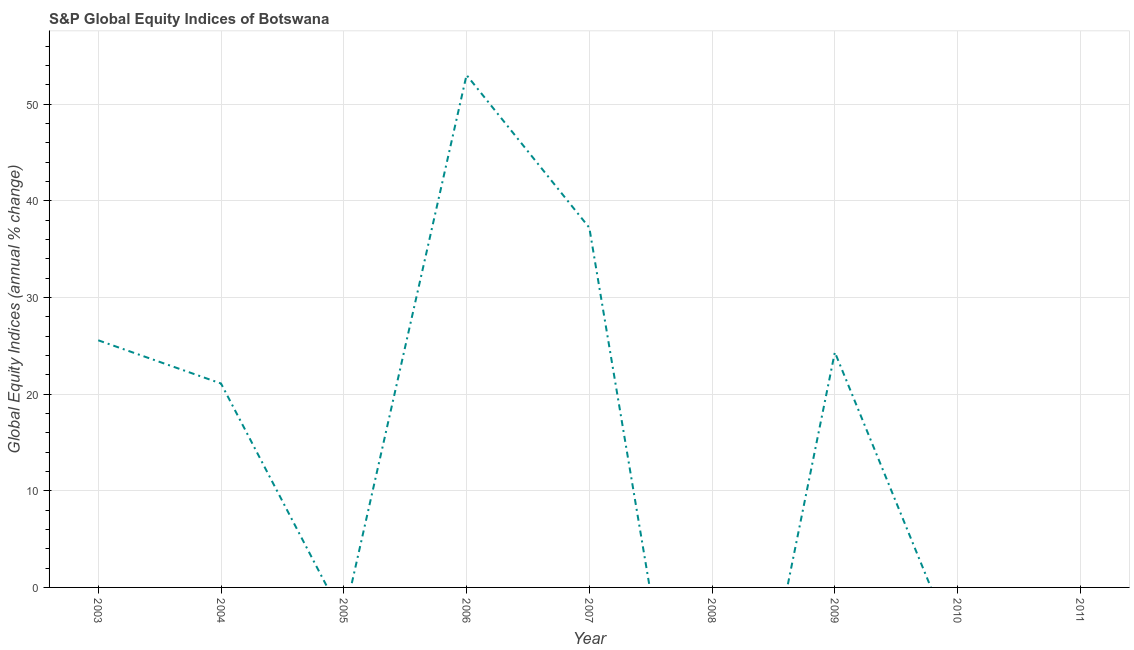What is the s&p global equity indices in 2007?
Keep it short and to the point. 37.21. Across all years, what is the maximum s&p global equity indices?
Offer a terse response. 53.02. In which year was the s&p global equity indices maximum?
Offer a very short reply. 2006. What is the sum of the s&p global equity indices?
Make the answer very short. 161.24. What is the difference between the s&p global equity indices in 2004 and 2006?
Keep it short and to the point. -31.92. What is the average s&p global equity indices per year?
Offer a terse response. 17.92. What is the median s&p global equity indices?
Provide a succinct answer. 21.1. In how many years, is the s&p global equity indices greater than 46 %?
Make the answer very short. 1. What is the ratio of the s&p global equity indices in 2004 to that in 2006?
Your response must be concise. 0.4. Is the difference between the s&p global equity indices in 2006 and 2007 greater than the difference between any two years?
Your response must be concise. No. What is the difference between the highest and the second highest s&p global equity indices?
Offer a very short reply. 15.8. What is the difference between the highest and the lowest s&p global equity indices?
Offer a very short reply. 53.02. In how many years, is the s&p global equity indices greater than the average s&p global equity indices taken over all years?
Your answer should be very brief. 5. Does the s&p global equity indices monotonically increase over the years?
Your response must be concise. No. Are the values on the major ticks of Y-axis written in scientific E-notation?
Provide a short and direct response. No. Does the graph contain any zero values?
Your answer should be compact. Yes. Does the graph contain grids?
Your answer should be very brief. Yes. What is the title of the graph?
Provide a short and direct response. S&P Global Equity Indices of Botswana. What is the label or title of the X-axis?
Your answer should be compact. Year. What is the label or title of the Y-axis?
Offer a very short reply. Global Equity Indices (annual % change). What is the Global Equity Indices (annual % change) of 2003?
Offer a terse response. 25.57. What is the Global Equity Indices (annual % change) in 2004?
Offer a very short reply. 21.1. What is the Global Equity Indices (annual % change) in 2005?
Make the answer very short. 0. What is the Global Equity Indices (annual % change) in 2006?
Provide a succinct answer. 53.02. What is the Global Equity Indices (annual % change) in 2007?
Your response must be concise. 37.21. What is the Global Equity Indices (annual % change) of 2008?
Make the answer very short. 0. What is the Global Equity Indices (annual % change) of 2009?
Your answer should be compact. 24.33. What is the difference between the Global Equity Indices (annual % change) in 2003 and 2004?
Keep it short and to the point. 4.47. What is the difference between the Global Equity Indices (annual % change) in 2003 and 2006?
Your answer should be very brief. -27.45. What is the difference between the Global Equity Indices (annual % change) in 2003 and 2007?
Make the answer very short. -11.64. What is the difference between the Global Equity Indices (annual % change) in 2003 and 2009?
Provide a short and direct response. 1.24. What is the difference between the Global Equity Indices (annual % change) in 2004 and 2006?
Make the answer very short. -31.92. What is the difference between the Global Equity Indices (annual % change) in 2004 and 2007?
Keep it short and to the point. -16.11. What is the difference between the Global Equity Indices (annual % change) in 2004 and 2009?
Keep it short and to the point. -3.23. What is the difference between the Global Equity Indices (annual % change) in 2006 and 2007?
Keep it short and to the point. 15.8. What is the difference between the Global Equity Indices (annual % change) in 2006 and 2009?
Your answer should be very brief. 28.68. What is the difference between the Global Equity Indices (annual % change) in 2007 and 2009?
Keep it short and to the point. 12.88. What is the ratio of the Global Equity Indices (annual % change) in 2003 to that in 2004?
Provide a short and direct response. 1.21. What is the ratio of the Global Equity Indices (annual % change) in 2003 to that in 2006?
Keep it short and to the point. 0.48. What is the ratio of the Global Equity Indices (annual % change) in 2003 to that in 2007?
Give a very brief answer. 0.69. What is the ratio of the Global Equity Indices (annual % change) in 2003 to that in 2009?
Your answer should be compact. 1.05. What is the ratio of the Global Equity Indices (annual % change) in 2004 to that in 2006?
Keep it short and to the point. 0.4. What is the ratio of the Global Equity Indices (annual % change) in 2004 to that in 2007?
Offer a terse response. 0.57. What is the ratio of the Global Equity Indices (annual % change) in 2004 to that in 2009?
Your response must be concise. 0.87. What is the ratio of the Global Equity Indices (annual % change) in 2006 to that in 2007?
Provide a short and direct response. 1.43. What is the ratio of the Global Equity Indices (annual % change) in 2006 to that in 2009?
Provide a short and direct response. 2.18. What is the ratio of the Global Equity Indices (annual % change) in 2007 to that in 2009?
Provide a succinct answer. 1.53. 